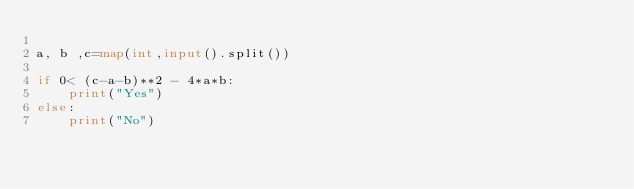<code> <loc_0><loc_0><loc_500><loc_500><_Python_>
a, b ,c=map(int,input().split())

if 0< (c-a-b)**2 - 4*a*b:
    print("Yes")
else:
    print("No")
</code> 